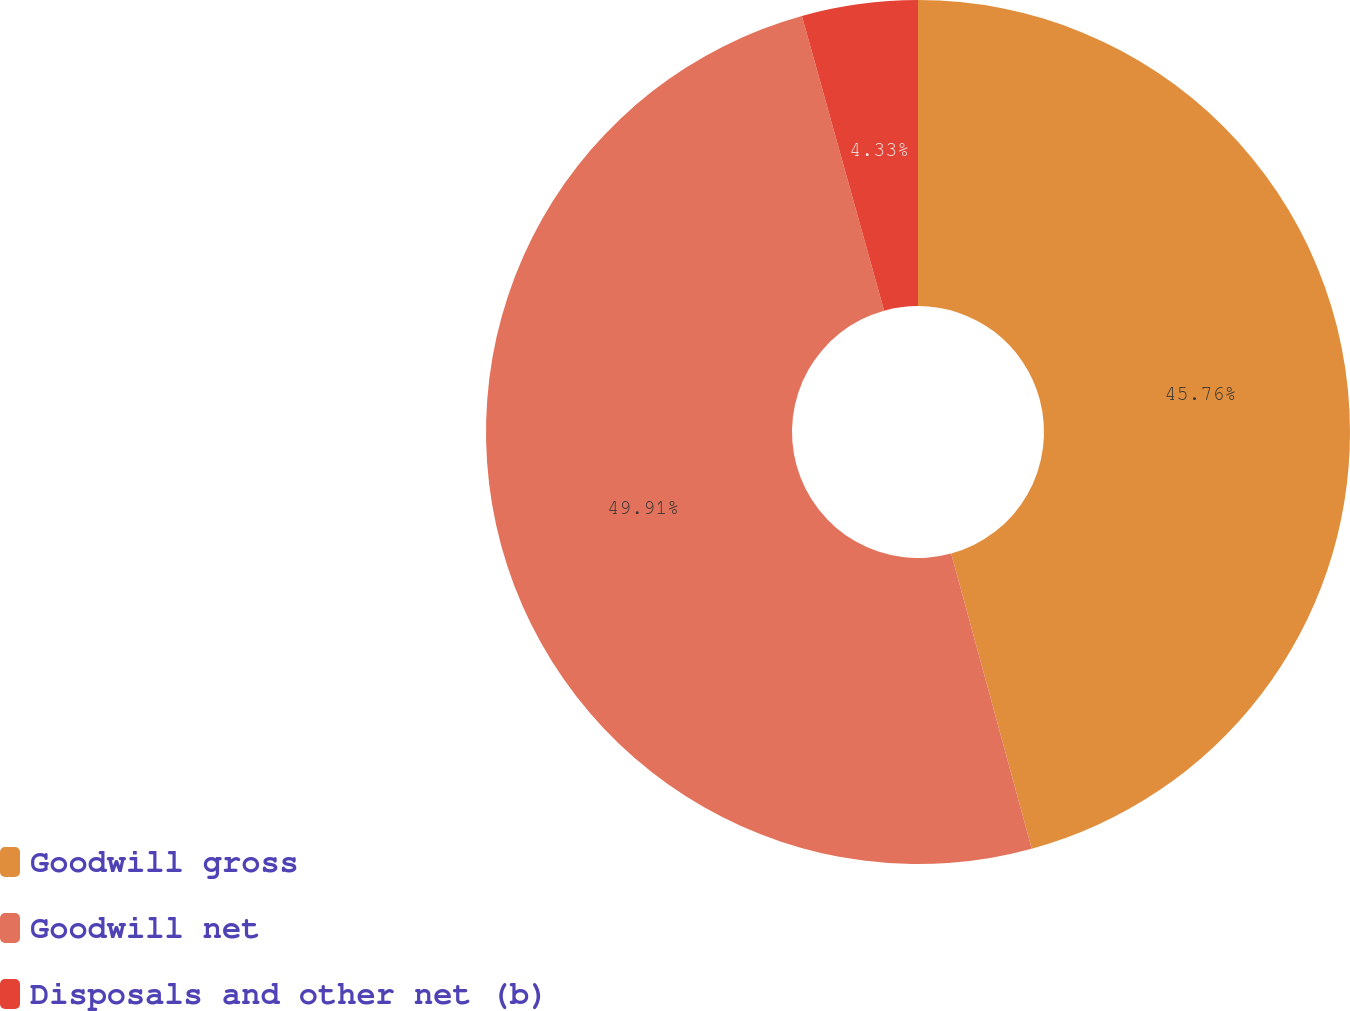Convert chart to OTSL. <chart><loc_0><loc_0><loc_500><loc_500><pie_chart><fcel>Goodwill gross<fcel>Goodwill net<fcel>Disposals and other net (b)<nl><fcel>45.76%<fcel>49.91%<fcel>4.33%<nl></chart> 